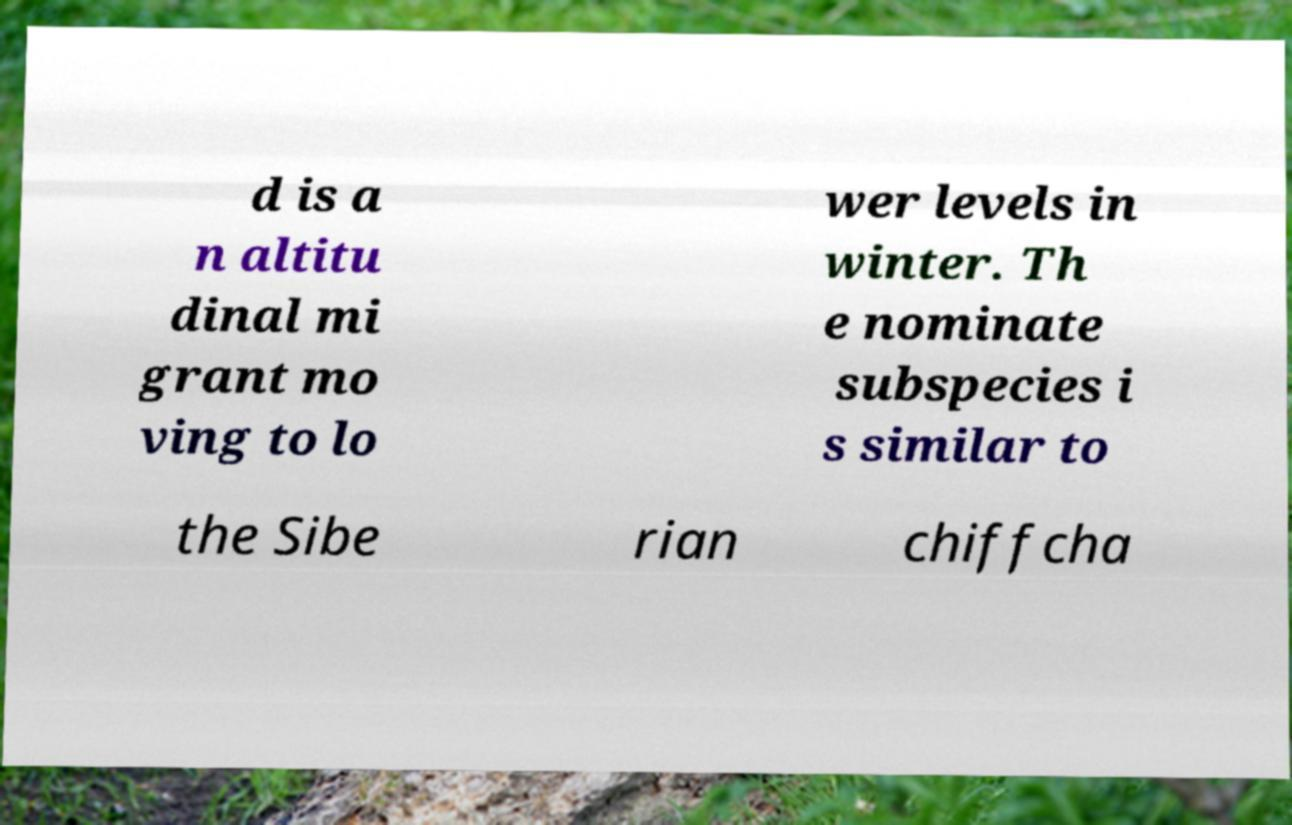Can you accurately transcribe the text from the provided image for me? d is a n altitu dinal mi grant mo ving to lo wer levels in winter. Th e nominate subspecies i s similar to the Sibe rian chiffcha 